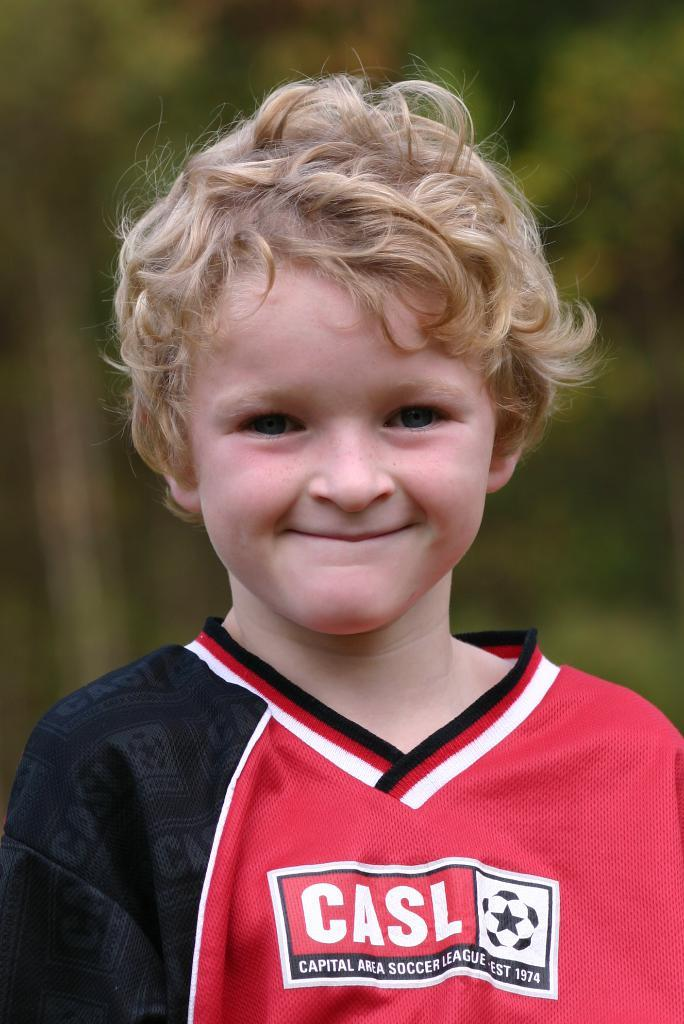<image>
Provide a brief description of the given image. A blonde boy with a red, black and white shirt that says casl on his chest. 